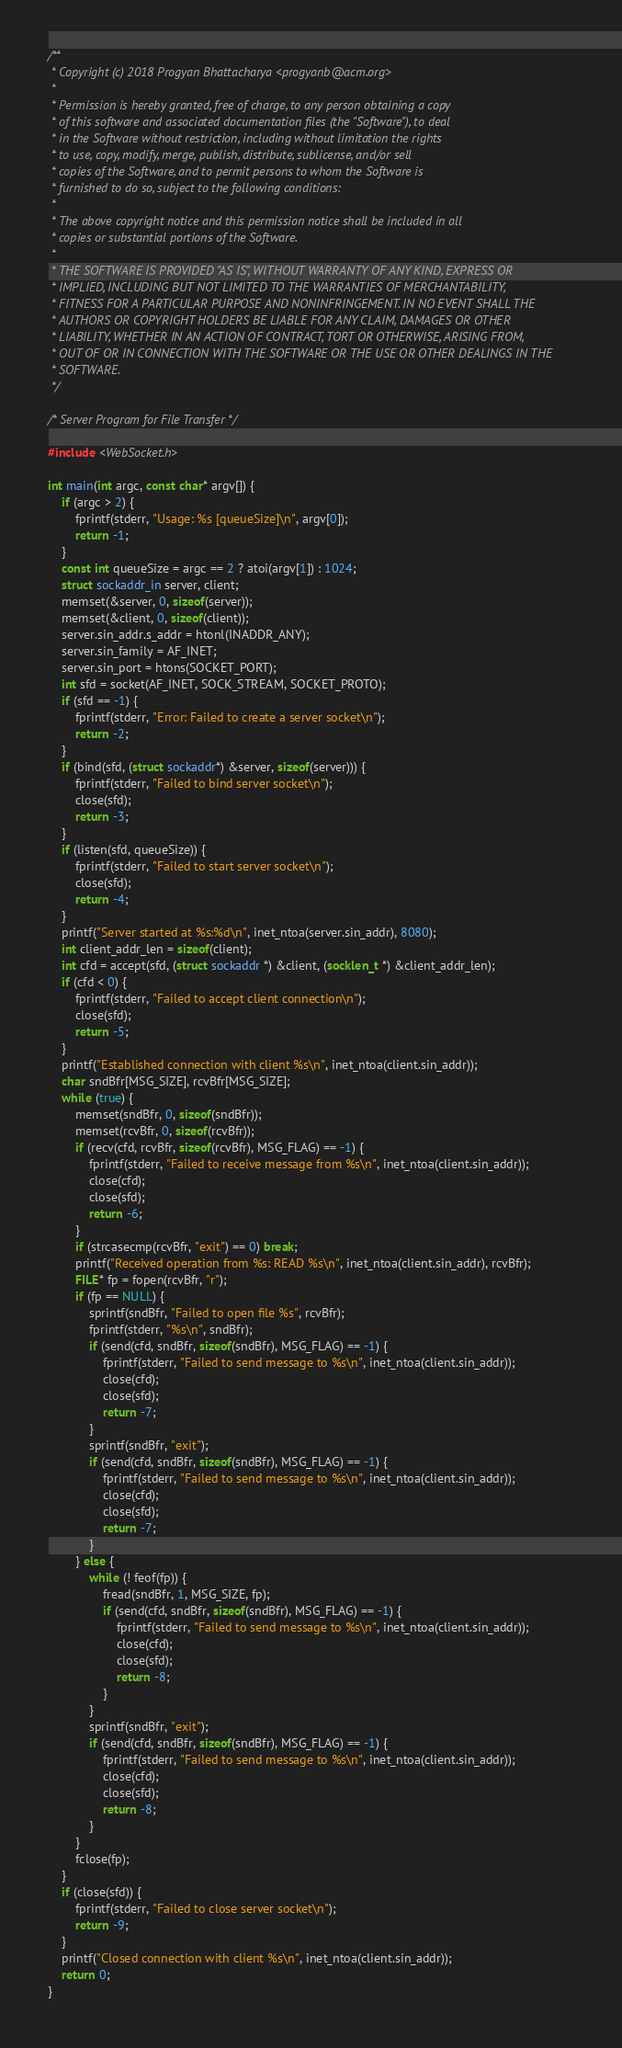Convert code to text. <code><loc_0><loc_0><loc_500><loc_500><_C_>/**
 * Copyright (c) 2018 Progyan Bhattacharya <progyanb@acm.org>
 *
 * Permission is hereby granted, free of charge, to any person obtaining a copy
 * of this software and associated documentation files (the "Software"), to deal
 * in the Software without restriction, including without limitation the rights
 * to use, copy, modify, merge, publish, distribute, sublicense, and/or sell
 * copies of the Software, and to permit persons to whom the Software is
 * furnished to do so, subject to the following conditions:
 *
 * The above copyright notice and this permission notice shall be included in all
 * copies or substantial portions of the Software.
 *
 * THE SOFTWARE IS PROVIDED "AS IS", WITHOUT WARRANTY OF ANY KIND, EXPRESS OR
 * IMPLIED, INCLUDING BUT NOT LIMITED TO THE WARRANTIES OF MERCHANTABILITY,
 * FITNESS FOR A PARTICULAR PURPOSE AND NONINFRINGEMENT. IN NO EVENT SHALL THE
 * AUTHORS OR COPYRIGHT HOLDERS BE LIABLE FOR ANY CLAIM, DAMAGES OR OTHER
 * LIABILITY, WHETHER IN AN ACTION OF CONTRACT, TORT OR OTHERWISE, ARISING FROM,
 * OUT OF OR IN CONNECTION WITH THE SOFTWARE OR THE USE OR OTHER DEALINGS IN THE
 * SOFTWARE.
 */

/* Server Program for File Transfer */

#include <WebSocket.h>

int main(int argc, const char* argv[]) {
    if (argc > 2) {
        fprintf(stderr, "Usage: %s [queueSize]\n", argv[0]);
        return -1;
    }
    const int queueSize = argc == 2 ? atoi(argv[1]) : 1024;
    struct sockaddr_in server, client;
    memset(&server, 0, sizeof(server));
    memset(&client, 0, sizeof(client));
    server.sin_addr.s_addr = htonl(INADDR_ANY);
    server.sin_family = AF_INET;
    server.sin_port = htons(SOCKET_PORT);
    int sfd = socket(AF_INET, SOCK_STREAM, SOCKET_PROTO);
    if (sfd == -1) {
        fprintf(stderr, "Error: Failed to create a server socket\n");
        return -2;
    }
    if (bind(sfd, (struct sockaddr*) &server, sizeof(server))) {
        fprintf(stderr, "Failed to bind server socket\n");
        close(sfd);
        return -3;
    }
    if (listen(sfd, queueSize)) {
        fprintf(stderr, "Failed to start server socket\n");
        close(sfd);
        return -4;
    }
    printf("Server started at %s:%d\n", inet_ntoa(server.sin_addr), 8080);
    int client_addr_len = sizeof(client);
    int cfd = accept(sfd, (struct sockaddr *) &client, (socklen_t *) &client_addr_len);
    if (cfd < 0) {
        fprintf(stderr, "Failed to accept client connection\n");
        close(sfd);
        return -5;
    }
    printf("Established connection with client %s\n", inet_ntoa(client.sin_addr));
    char sndBfr[MSG_SIZE], rcvBfr[MSG_SIZE];
    while (true) {
        memset(sndBfr, 0, sizeof(sndBfr));
        memset(rcvBfr, 0, sizeof(rcvBfr));
        if (recv(cfd, rcvBfr, sizeof(rcvBfr), MSG_FLAG) == -1) {
            fprintf(stderr, "Failed to receive message from %s\n", inet_ntoa(client.sin_addr));
            close(cfd);
            close(sfd);
            return -6;
        }
        if (strcasecmp(rcvBfr, "exit") == 0) break;
        printf("Received operation from %s: READ %s\n", inet_ntoa(client.sin_addr), rcvBfr);
        FILE* fp = fopen(rcvBfr, "r");
        if (fp == NULL) {
            sprintf(sndBfr, "Failed to open file %s", rcvBfr);
            fprintf(stderr, "%s\n", sndBfr);
            if (send(cfd, sndBfr, sizeof(sndBfr), MSG_FLAG) == -1) {
                fprintf(stderr, "Failed to send message to %s\n", inet_ntoa(client.sin_addr));
                close(cfd);
                close(sfd);
                return -7;
            }
            sprintf(sndBfr, "exit");
            if (send(cfd, sndBfr, sizeof(sndBfr), MSG_FLAG) == -1) {
                fprintf(stderr, "Failed to send message to %s\n", inet_ntoa(client.sin_addr));
                close(cfd);
                close(sfd);
                return -7;
            }
        } else {
            while (! feof(fp)) {
                fread(sndBfr, 1, MSG_SIZE, fp);
                if (send(cfd, sndBfr, sizeof(sndBfr), MSG_FLAG) == -1) {
                    fprintf(stderr, "Failed to send message to %s\n", inet_ntoa(client.sin_addr));
                    close(cfd);
                    close(sfd);
                    return -8;
                }
            }
            sprintf(sndBfr, "exit");
            if (send(cfd, sndBfr, sizeof(sndBfr), MSG_FLAG) == -1) {
                fprintf(stderr, "Failed to send message to %s\n", inet_ntoa(client.sin_addr));
                close(cfd);
                close(sfd);
                return -8;
            }
        }
        fclose(fp);
    }
    if (close(sfd)) {
        fprintf(stderr, "Failed to close server socket\n");
        return -9;
    }
    printf("Closed connection with client %s\n", inet_ntoa(client.sin_addr));
    return 0;
}
</code> 